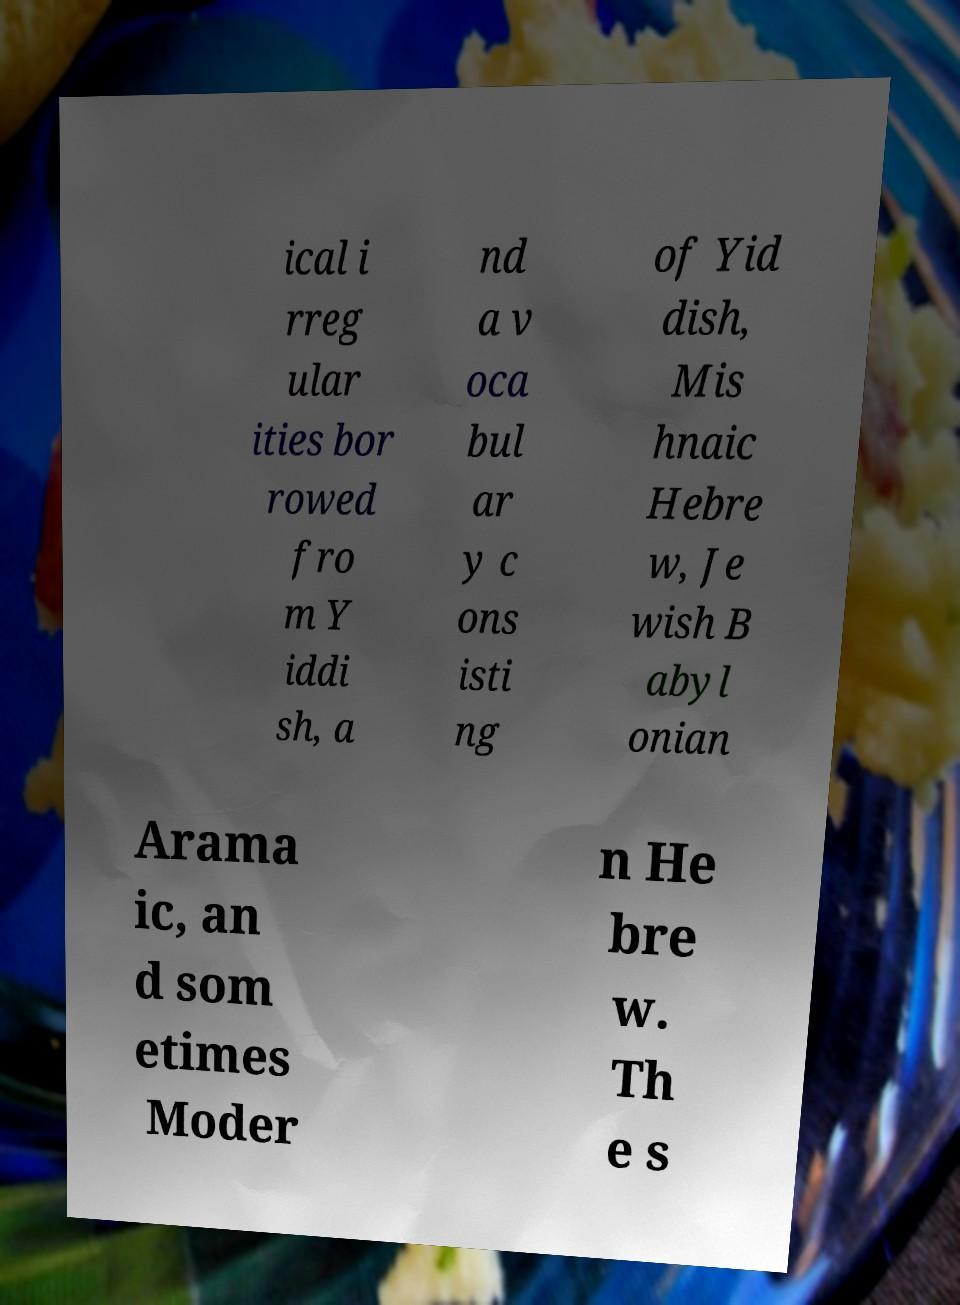Could you extract and type out the text from this image? ical i rreg ular ities bor rowed fro m Y iddi sh, a nd a v oca bul ar y c ons isti ng of Yid dish, Mis hnaic Hebre w, Je wish B abyl onian Arama ic, an d som etimes Moder n He bre w. Th e s 